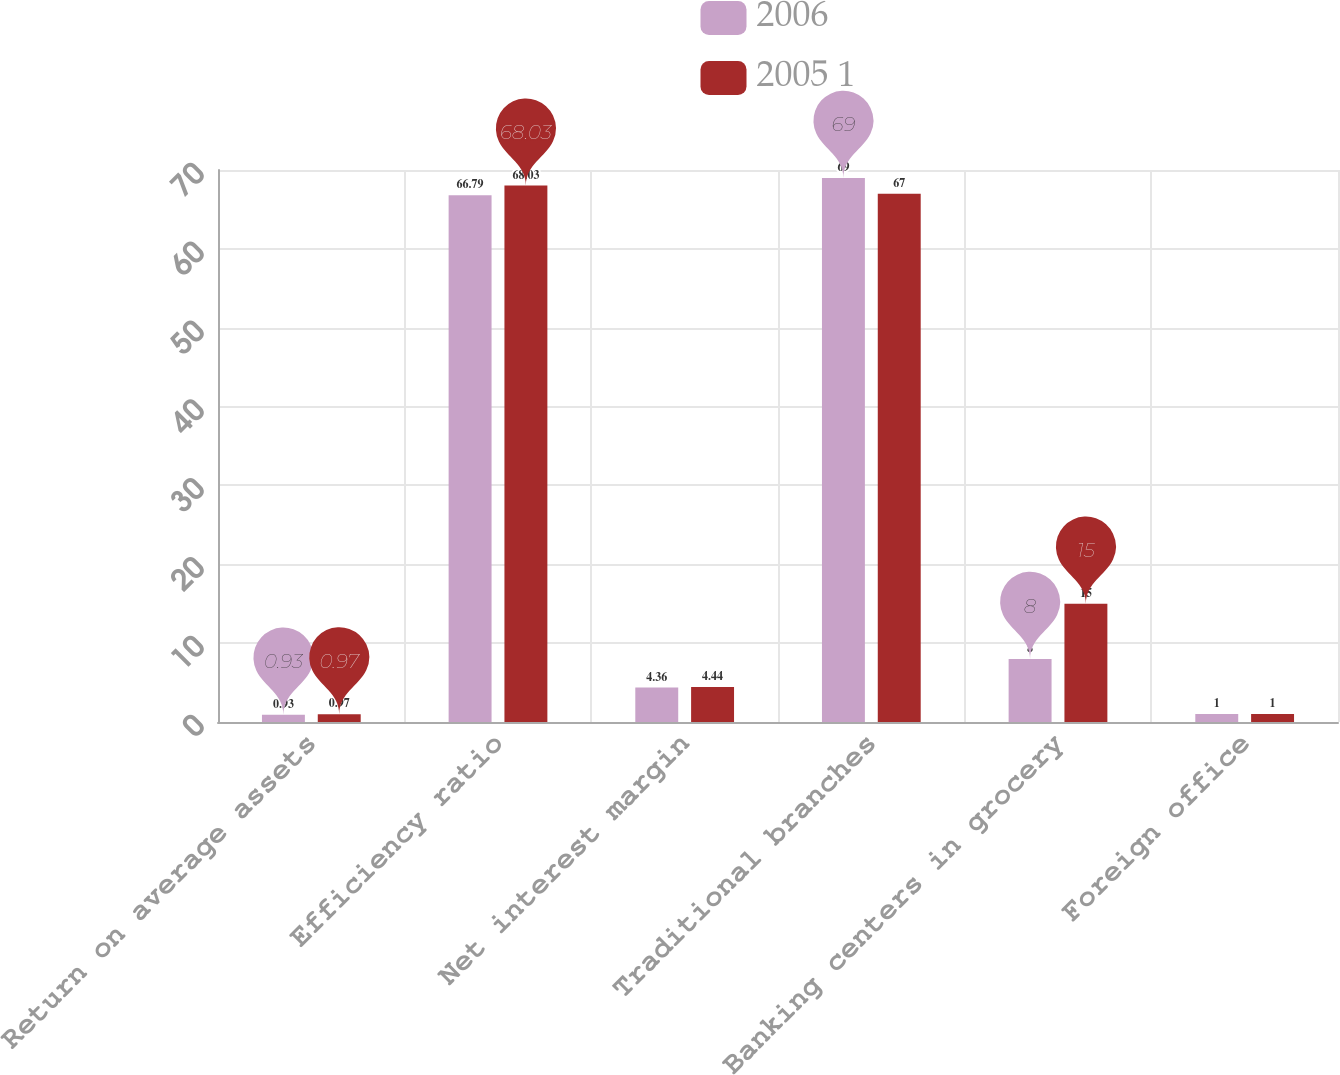Convert chart to OTSL. <chart><loc_0><loc_0><loc_500><loc_500><stacked_bar_chart><ecel><fcel>Return on average assets<fcel>Efficiency ratio<fcel>Net interest margin<fcel>Traditional branches<fcel>Banking centers in grocery<fcel>Foreign office<nl><fcel>2006<fcel>0.93<fcel>66.79<fcel>4.36<fcel>69<fcel>8<fcel>1<nl><fcel>2005 1<fcel>0.97<fcel>68.03<fcel>4.44<fcel>67<fcel>15<fcel>1<nl></chart> 